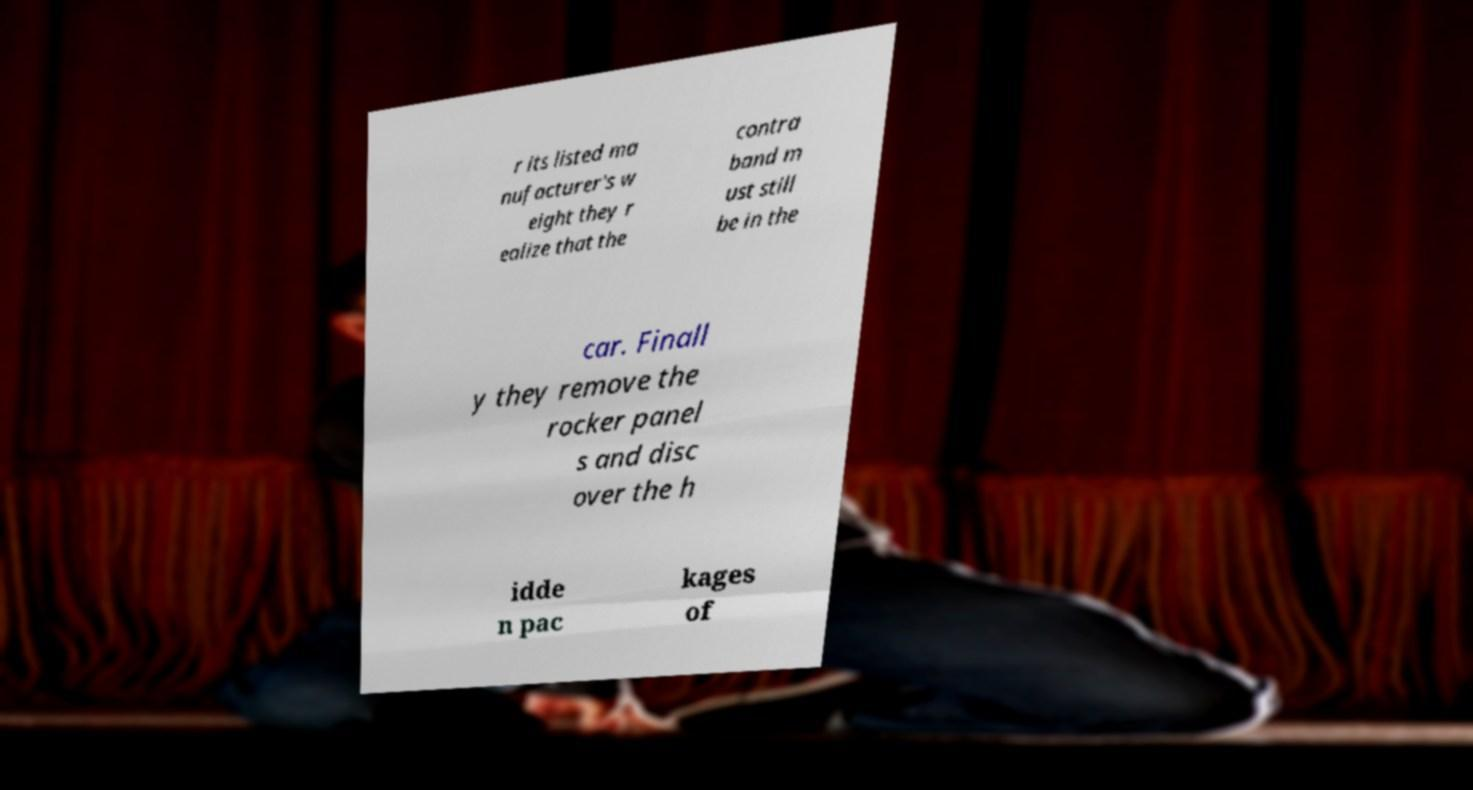Can you read and provide the text displayed in the image?This photo seems to have some interesting text. Can you extract and type it out for me? r its listed ma nufacturer's w eight they r ealize that the contra band m ust still be in the car. Finall y they remove the rocker panel s and disc over the h idde n pac kages of 